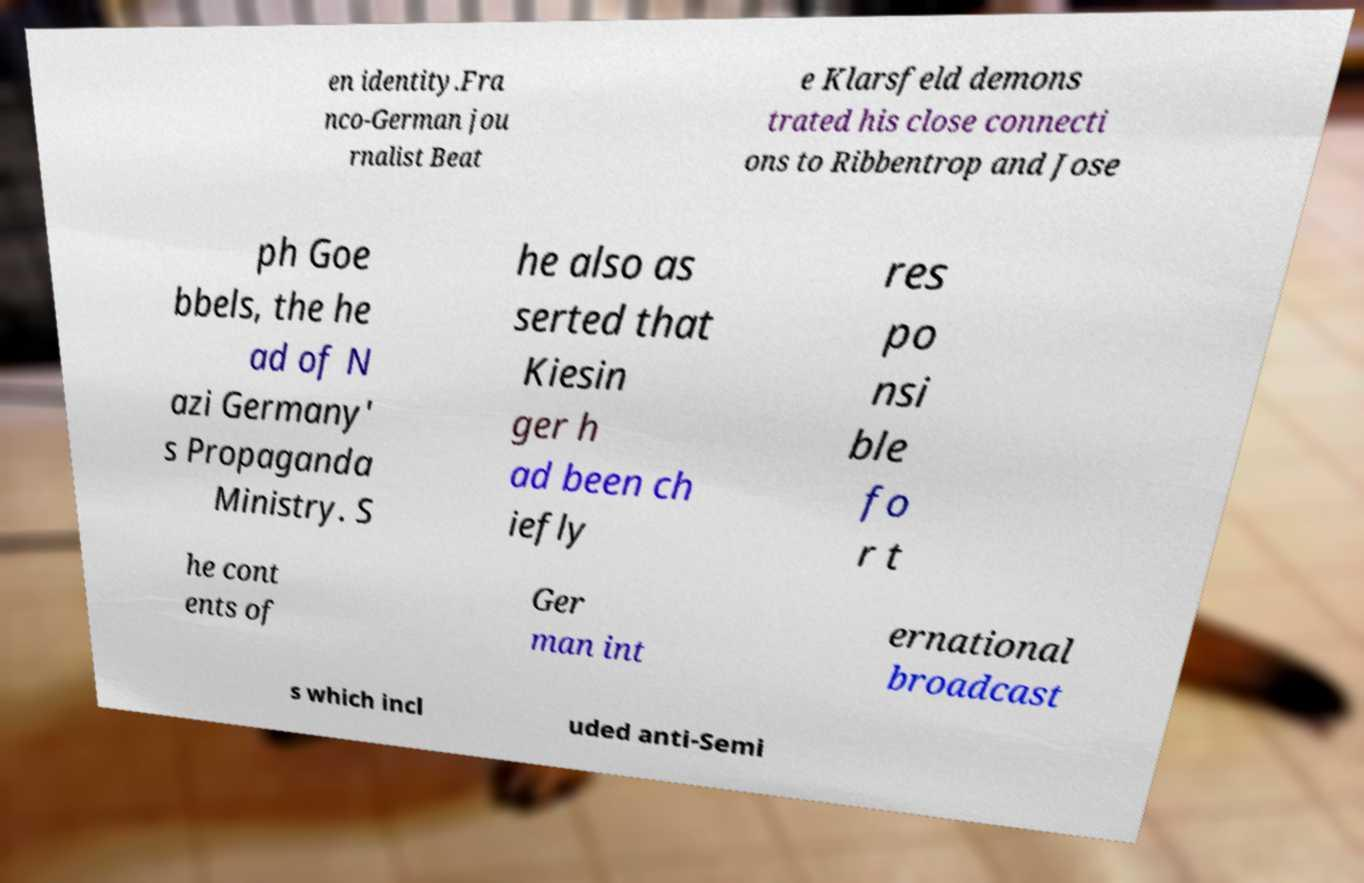Please identify and transcribe the text found in this image. en identity.Fra nco-German jou rnalist Beat e Klarsfeld demons trated his close connecti ons to Ribbentrop and Jose ph Goe bbels, the he ad of N azi Germany' s Propaganda Ministry. S he also as serted that Kiesin ger h ad been ch iefly res po nsi ble fo r t he cont ents of Ger man int ernational broadcast s which incl uded anti-Semi 